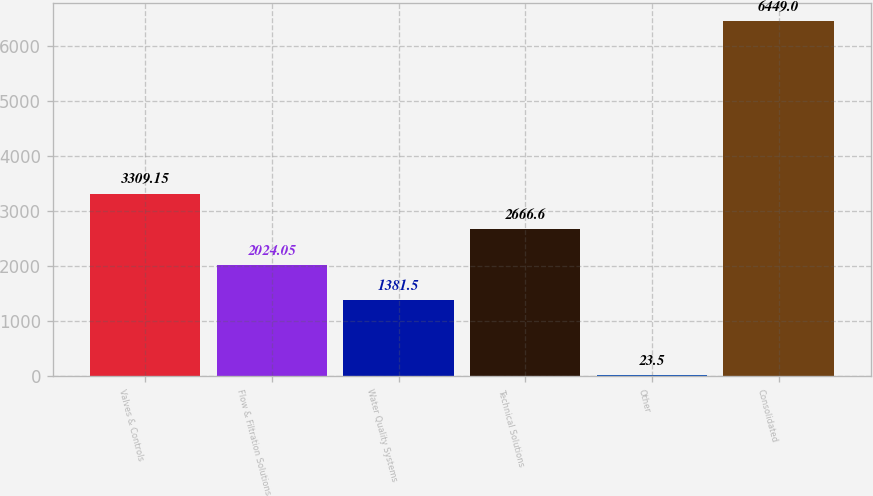<chart> <loc_0><loc_0><loc_500><loc_500><bar_chart><fcel>Valves & Controls<fcel>Flow & Filtration Solutions<fcel>Water Quality Systems<fcel>Technical Solutions<fcel>Other<fcel>Consolidated<nl><fcel>3309.15<fcel>2024.05<fcel>1381.5<fcel>2666.6<fcel>23.5<fcel>6449<nl></chart> 